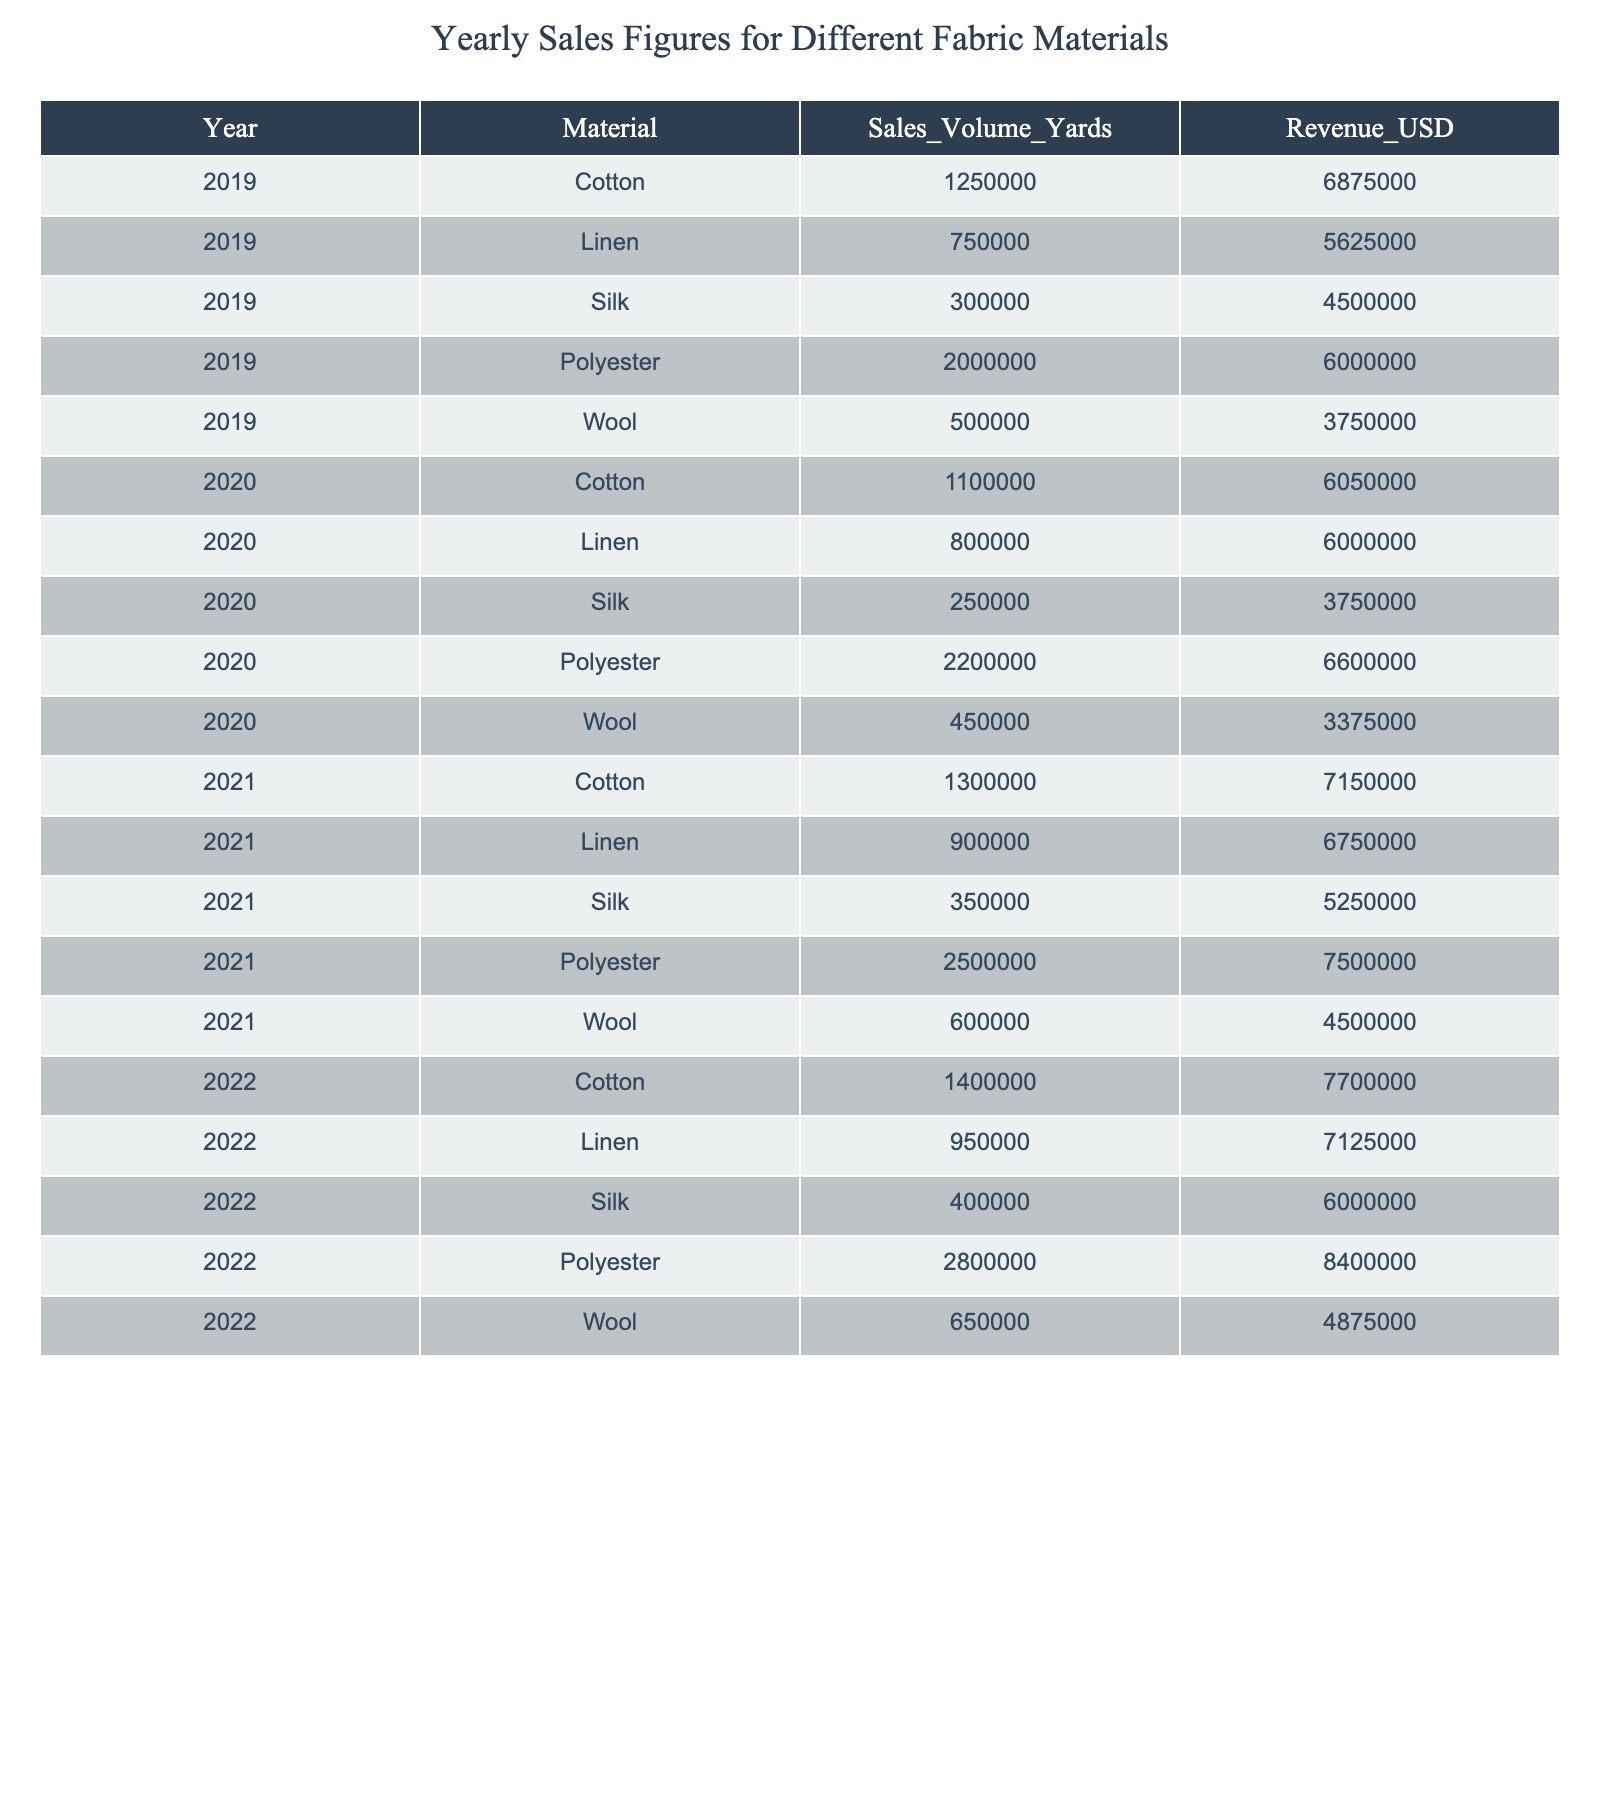What was the total sales volume of Polyester in 2021? In 2021, the sales volume for Polyester is listed as 2,500,000 yards.
Answer: 2,500,000 yards How much revenue did Wool generate in 2020? The table shows that Wool generated 3,375,000 USD in revenue in 2020.
Answer: 3,375,000 USD Which fabric material had the highest sales volume in 2022? In 2022, the sales volume of Polyester is 2,800,000 yards, which is the highest among all materials.
Answer: Polyester What was the average sales volume for Cotton over the years 2019 to 2022? The sales volumes for Cotton from 2019 to 2022 are 1,250,000, 1,100,000, 1,300,000, and 1,400,000 yards. Summing these gives 5,050,000 yards, and dividing by 4 results in an average of 1,262,500 yards.
Answer: 1,262,500 yards Did the sales revenue for Silk increase from 2019 to 2022? Looking at the revenue figures for Silk: 4,500,000 USD in 2019, 3,750,000 USD in 2020, 5,250,000 USD in 2021, and 6,000,000 USD in 2022; there was a decrease in 2020, followed by increases in subsequent years. Therefore, overall, it did increase despite the dip in 2020.
Answer: Yes What is the percentage increase in revenue for Linen from 2019 to 2022? The revenue for Linen in 2019 was 5,625,000 USD, and in 2022 it was 7,125,000 USD. The difference is 1,500,000 USD. To find the percentage increase: (1,500,000 / 5,625,000) * 100 = 26.67%.
Answer: 26.67% How much more revenue did Cotton generate compared to Wool in 2021? In 2021, Cotton generated 7,150,000 USD, while Wool generated 4,500,000 USD. The difference in revenue is 7,150,000 - 4,500,000 = 2,650,000 USD.
Answer: 2,650,000 USD What material had the lowest sales volume in 2019, and what was the volume? The table shows that Silk had the lowest sales volume in 2019 with 300,000 yards.
Answer: Silk, 300,000 yards Between 2019 and 2020, which fabric had the largest decrease in sales volume? For Cotton, the decrease was 125,000 yards, for Linen it was a decrease of 50,000 yards, for Silk, it was a decrease of 50,000 yards, for Polyester it increased by 200,000 yards, and Wool dropped by 50,000 yards. Thus, Cotton had the largest decrease.
Answer: Cotton Was there any year in which Polyester had a revenue less than 6 million USD? The revenue for Polyester in 2019 was 6,000,000 USD, and in 2020 it increased to 6,600,000 USD. From 2021 to 2022, the revenue did not drop below 6 million USD. Therefore, there was no year with revenue less than 6 million USD.
Answer: No 